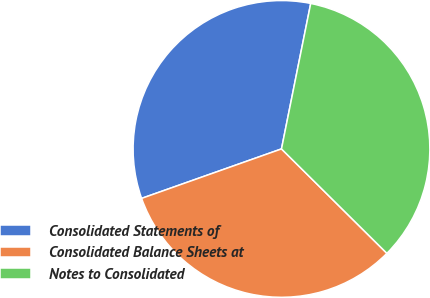<chart> <loc_0><loc_0><loc_500><loc_500><pie_chart><fcel>Consolidated Statements of<fcel>Consolidated Balance Sheets at<fcel>Notes to Consolidated<nl><fcel>33.57%<fcel>32.17%<fcel>34.27%<nl></chart> 